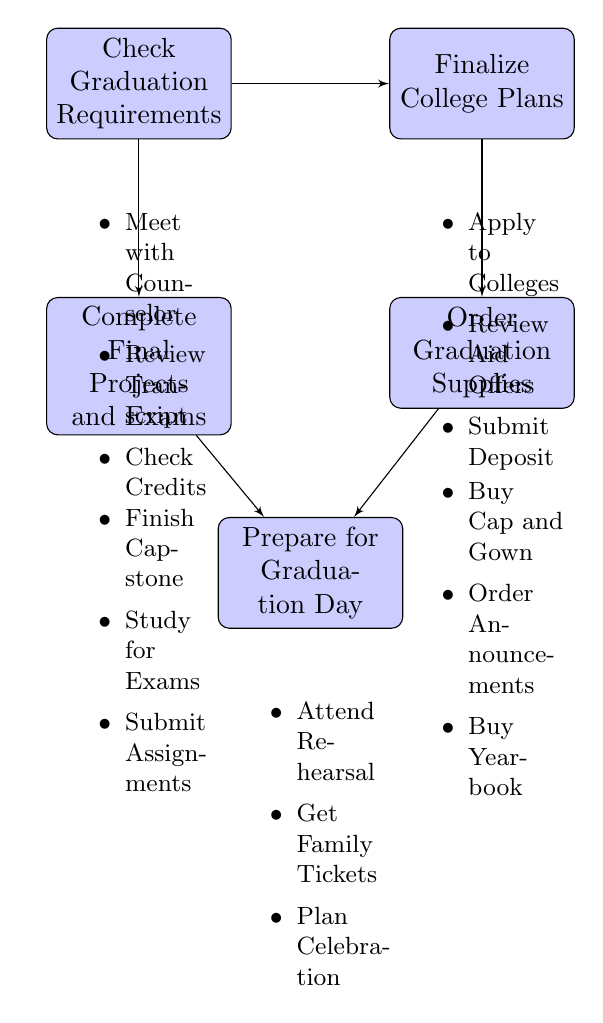What is the first key step in preparing for graduation? The first key step listed in the diagram is "Check Graduation Requirements." It is the topmost node in the flow chart.
Answer: Check Graduation Requirements How many key steps are there in total in the diagram? From the diagram, there are five key steps outlined: Check Graduation Requirements, Finalize College Plans, Complete Final Projects and Exams, Order Graduation Supplies, and Prepare for Graduation Day.
Answer: Five What is the last step before graduation day? The last step before graduation day, as shown in the diagram, is "Prepare for Graduation Day," which consolidates the final preparations for graduation.
Answer: Prepare for Graduation Day Which step involves dealing with college applications? The step that involves college applications is "Finalize College Plans," which includes actions like applying to colleges and reviewing financial aid offers.
Answer: Finalize College Plans What are the details listed for the "Order Graduation Supplies" step? The details for "Order Graduation Supplies" include purchasing a cap and gown, ordering graduation announcements, and buying a yearbook, as represented in the diagram below the step.
Answer: Purchase Cap and Gown, Order Graduation Announcements, Buy Yearbook Which two steps lead to the "Prepare for Graduation Day" node? The two steps that lead to "Prepare for Graduation Day" are "Complete Final Projects and Exams" and "Order Graduation Supplies." Both steps are shown to connect to this final preparation node.
Answer: Complete Final Projects and Exams, Order Graduation Supplies What action should be taken during "Complete Final Projects and Exams"? Under the "Complete Final Projects and Exams" step, one should finish the senior capstone project, study for final exams, and submit all assignments.
Answer: Finish Senior Capstone Project, Study for Final Exams, Submit All Assignments What is the connection between "Check Graduation Requirements" and "Finalize College Plans"? "Check Graduation Requirements" connects to "Finalize College Plans," indicating that ensuring requirements are met is a precursor to finalizing plans for college.
Answer: Sequential relationship 